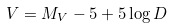Convert formula to latex. <formula><loc_0><loc_0><loc_500><loc_500>V = M _ { V } - 5 + 5 \log D</formula> 